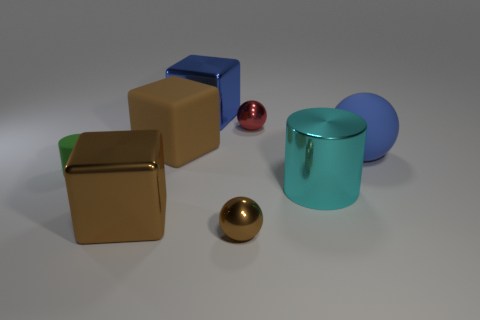Subtract all large brown metal cubes. How many cubes are left? 2 Add 1 metal cylinders. How many objects exist? 9 Subtract all balls. How many objects are left? 5 Subtract all brown balls. How many balls are left? 2 Add 5 metal cylinders. How many metal cylinders exist? 6 Subtract 0 cyan balls. How many objects are left? 8 Subtract 2 balls. How many balls are left? 1 Subtract all yellow balls. Subtract all blue cylinders. How many balls are left? 3 Subtract all yellow cylinders. How many blue cubes are left? 1 Subtract all small metal things. Subtract all small blue spheres. How many objects are left? 6 